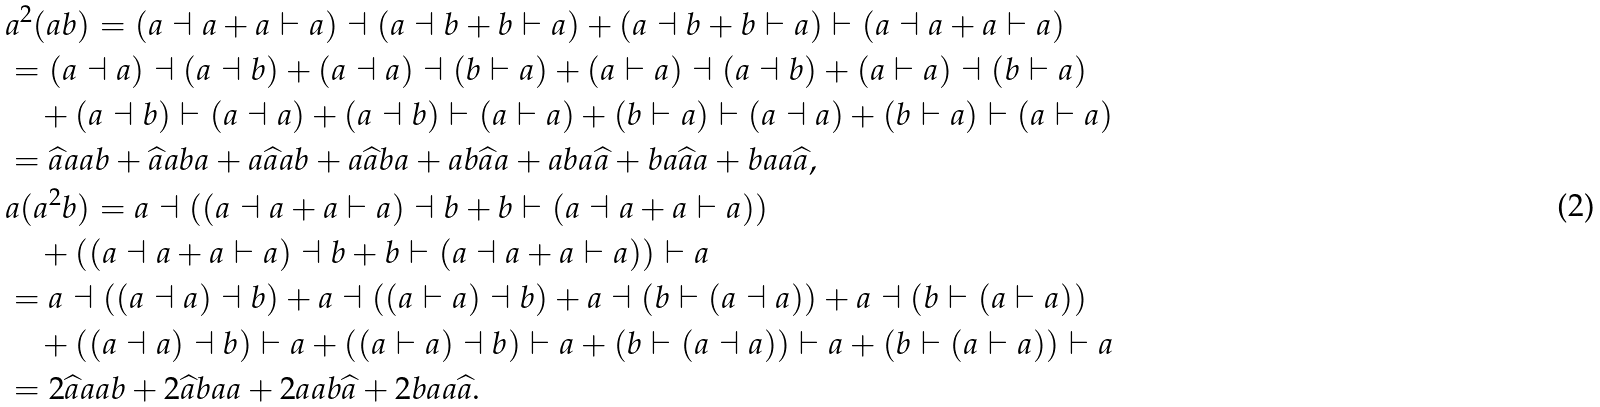Convert formula to latex. <formula><loc_0><loc_0><loc_500><loc_500>& a ^ { 2 } ( a b ) = ( a \dashv a + a \vdash a ) \dashv ( a \dashv b + b \vdash a ) + ( a \dashv b + b \vdash a ) \vdash ( a \dashv a + a \vdash a ) \\ & = ( a \dashv a ) \dashv ( a \dashv b ) + ( a \dashv a ) \dashv ( b \vdash a ) + ( a \vdash a ) \dashv ( a \dashv b ) + ( a \vdash a ) \dashv ( b \vdash a ) \\ & \quad + ( a \dashv b ) \vdash ( a \dashv a ) + ( a \dashv b ) \vdash ( a \vdash a ) + ( b \vdash a ) \vdash ( a \dashv a ) + ( b \vdash a ) \vdash ( a \vdash a ) \\ & = \widehat { a } a a b + \widehat { a } a b a + a \widehat { a } a b + a \widehat { a } b a + a b \widehat { a } a + a b a \widehat { a } + b a \widehat { a } a + b a a \widehat { a } , \\ & a ( a ^ { 2 } b ) = a \dashv ( ( a \dashv a + a \vdash a ) \dashv b + b \vdash ( a \dashv a + a \vdash a ) ) \\ & \quad + ( ( a \dashv a + a \vdash a ) \dashv b + b \vdash ( a \dashv a + a \vdash a ) ) \vdash a \\ & = a \dashv ( ( a \dashv a ) \dashv b ) + a \dashv ( ( a \vdash a ) \dashv b ) + a \dashv ( b \vdash ( a \dashv a ) ) + a \dashv ( b \vdash ( a \vdash a ) ) \\ & \quad + ( ( a \dashv a ) \dashv b ) \vdash a + ( ( a \vdash a ) \dashv b ) \vdash a + ( b \vdash ( a \dashv a ) ) \vdash a + ( b \vdash ( a \vdash a ) ) \vdash a \\ & = 2 \widehat { a } a a b + 2 \widehat { a } b a a + 2 a a b \widehat { a } + 2 b a a \widehat { a } .</formula> 